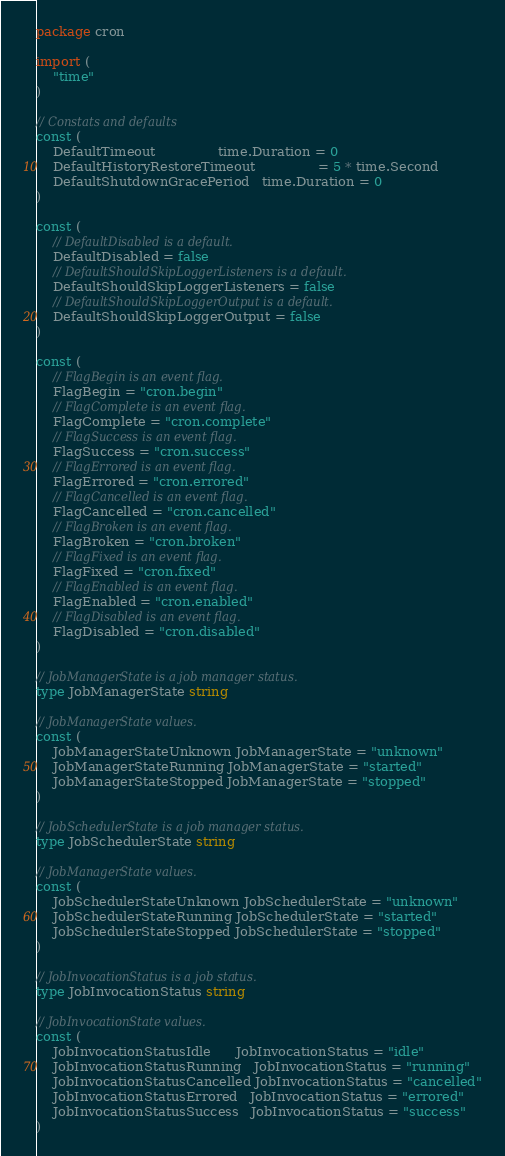Convert code to text. <code><loc_0><loc_0><loc_500><loc_500><_Go_>package cron

import (
	"time"
)

// Constats and defaults
const (
	DefaultTimeout               time.Duration = 0
	DefaultHistoryRestoreTimeout               = 5 * time.Second
	DefaultShutdownGracePeriod   time.Duration = 0
)

const (
	// DefaultDisabled is a default.
	DefaultDisabled = false
	// DefaultShouldSkipLoggerListeners is a default.
	DefaultShouldSkipLoggerListeners = false
	// DefaultShouldSkipLoggerOutput is a default.
	DefaultShouldSkipLoggerOutput = false
)

const (
	// FlagBegin is an event flag.
	FlagBegin = "cron.begin"
	// FlagComplete is an event flag.
	FlagComplete = "cron.complete"
	// FlagSuccess is an event flag.
	FlagSuccess = "cron.success"
	// FlagErrored is an event flag.
	FlagErrored = "cron.errored"
	// FlagCancelled is an event flag.
	FlagCancelled = "cron.cancelled"
	// FlagBroken is an event flag.
	FlagBroken = "cron.broken"
	// FlagFixed is an event flag.
	FlagFixed = "cron.fixed"
	// FlagEnabled is an event flag.
	FlagEnabled = "cron.enabled"
	// FlagDisabled is an event flag.
	FlagDisabled = "cron.disabled"
)

// JobManagerState is a job manager status.
type JobManagerState string

// JobManagerState values.
const (
	JobManagerStateUnknown JobManagerState = "unknown"
	JobManagerStateRunning JobManagerState = "started"
	JobManagerStateStopped JobManagerState = "stopped"
)

// JobSchedulerState is a job manager status.
type JobSchedulerState string

// JobManagerState values.
const (
	JobSchedulerStateUnknown JobSchedulerState = "unknown"
	JobSchedulerStateRunning JobSchedulerState = "started"
	JobSchedulerStateStopped JobSchedulerState = "stopped"
)

// JobInvocationStatus is a job status.
type JobInvocationStatus string

// JobInvocationState values.
const (
	JobInvocationStatusIdle      JobInvocationStatus = "idle"
	JobInvocationStatusRunning   JobInvocationStatus = "running"
	JobInvocationStatusCancelled JobInvocationStatus = "cancelled"
	JobInvocationStatusErrored   JobInvocationStatus = "errored"
	JobInvocationStatusSuccess   JobInvocationStatus = "success"
)
</code> 